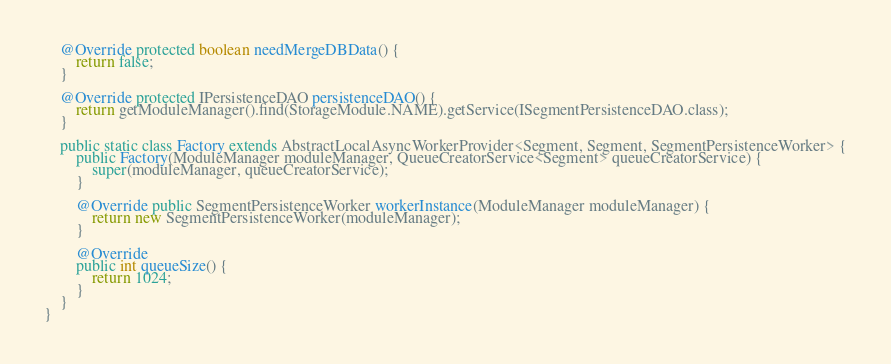Convert code to text. <code><loc_0><loc_0><loc_500><loc_500><_Java_>
    @Override protected boolean needMergeDBData() {
        return false;
    }

    @Override protected IPersistenceDAO persistenceDAO() {
        return getModuleManager().find(StorageModule.NAME).getService(ISegmentPersistenceDAO.class);
    }

    public static class Factory extends AbstractLocalAsyncWorkerProvider<Segment, Segment, SegmentPersistenceWorker> {
        public Factory(ModuleManager moduleManager, QueueCreatorService<Segment> queueCreatorService) {
            super(moduleManager, queueCreatorService);
        }

        @Override public SegmentPersistenceWorker workerInstance(ModuleManager moduleManager) {
            return new SegmentPersistenceWorker(moduleManager);
        }

        @Override
        public int queueSize() {
            return 1024;
        }
    }
}
</code> 